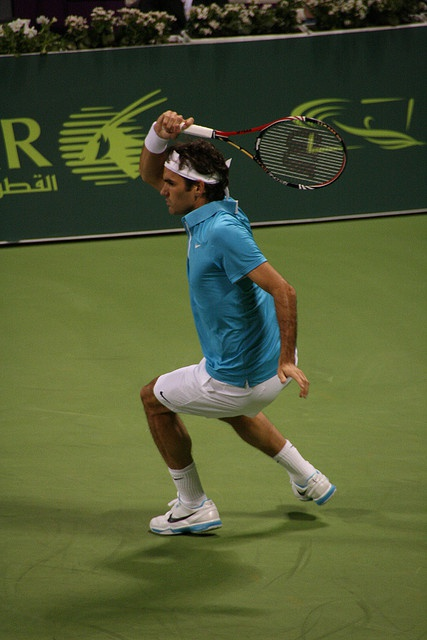Describe the objects in this image and their specific colors. I can see people in black, blue, darkgray, and olive tones, tennis racket in black, gray, darkgreen, and maroon tones, potted plant in black, darkgreen, and gray tones, potted plant in black, gray, and darkgreen tones, and potted plant in black, gray, and darkgreen tones in this image. 